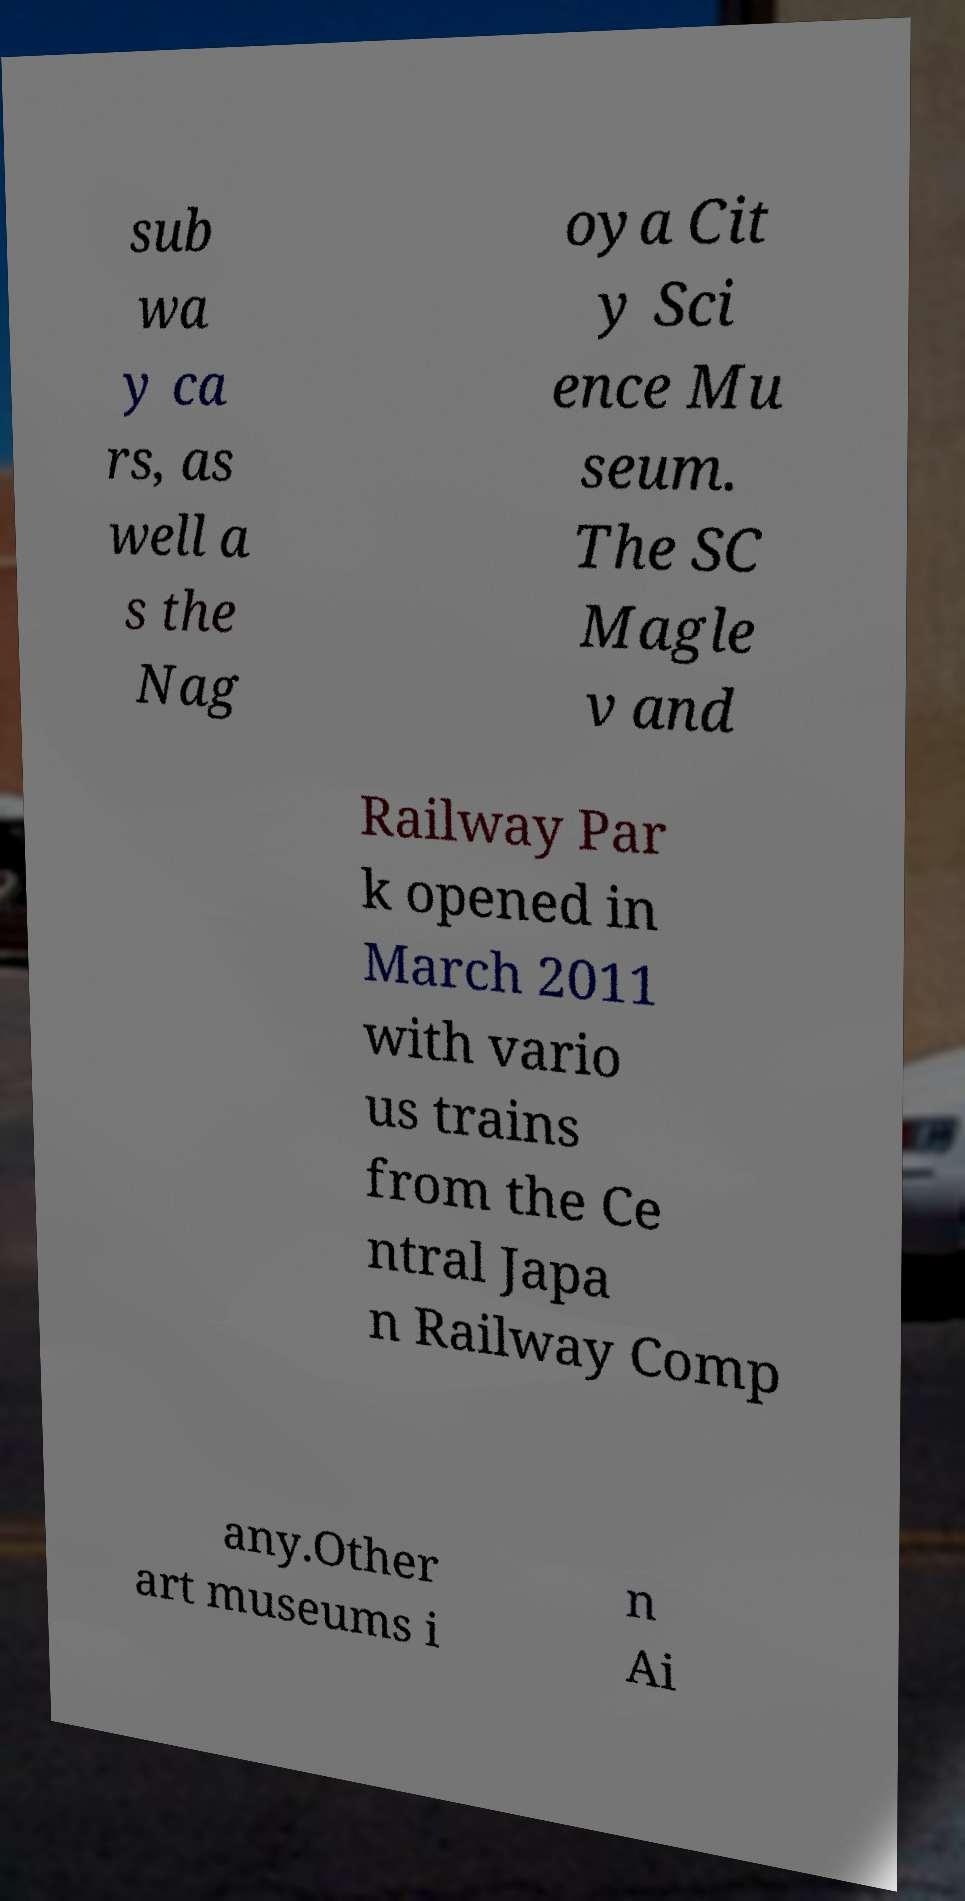Could you assist in decoding the text presented in this image and type it out clearly? sub wa y ca rs, as well a s the Nag oya Cit y Sci ence Mu seum. The SC Magle v and Railway Par k opened in March 2011 with vario us trains from the Ce ntral Japa n Railway Comp any.Other art museums i n Ai 